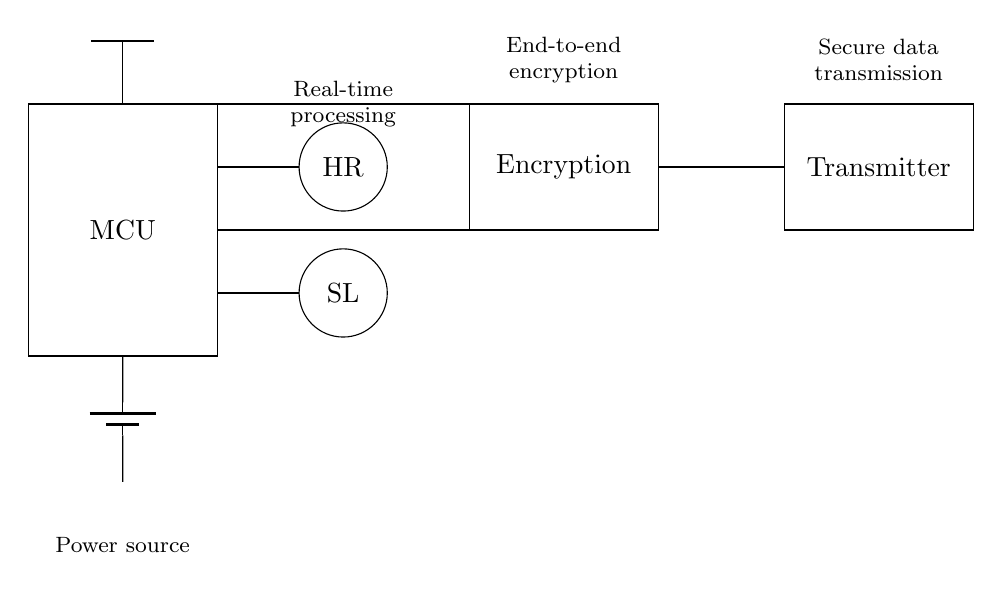What components are present in this circuit? The components are a microcontroller (MCU), heart rate sensor (HR), stress level sensor (SL), antenna, battery, encryption module, and transmitter. Each of these elements is clearly represented in the diagram based on standard symbols.
Answer: microcontroller, heart rate sensor, stress level sensor, antenna, battery, encryption module, transmitter What is the function of the encryption module? The encryption module's function is to provide end-to-end encryption, which ensures data security during transmission. Its purpose is critical since the device processes sensitive health data.
Answer: end-to-end encryption How many main sensors are included in the circuit? There are two main sensors: a heart rate sensor (HR) and a stress level sensor (SL). Their presence is indicated by the respective symbols in the diagram.
Answer: two How is the data transmitted from the sensors? The data from the sensors is transmitted through the data transmitter. The connections show that both the heart rate and stress level sensors interface with the microcontroller, which subsequently sends data to the transmitter for communication.
Answer: through the transmitter What type of power source is used in this circuit? The circuit uses a battery as its power source, indicated by the battery symbol in the diagram located at the bottom. The battery provides the necessary voltage to operate the components.
Answer: battery What does the antenna do in this circuit? The antenna is responsible for sending or receiving data wirelessly. It connects to the transmitter, enabling secure data transmission without the need for physical connections.
Answer: wireless data transmission What is the overall goal of this wearable device circuit? The overall goal is to monitor heart rate and stress levels while ensuring no personal data is stored. This is crucial for privacy-oriented applications, which is inferred from the inclusion of the encryption module.
Answer: monitor health without storing data 